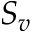<formula> <loc_0><loc_0><loc_500><loc_500>S _ { v }</formula> 